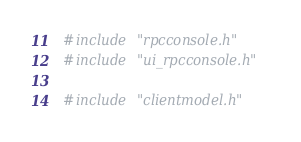Convert code to text. <code><loc_0><loc_0><loc_500><loc_500><_C++_>#include "rpcconsole.h"
#include "ui_rpcconsole.h"

#include "clientmodel.h"</code> 